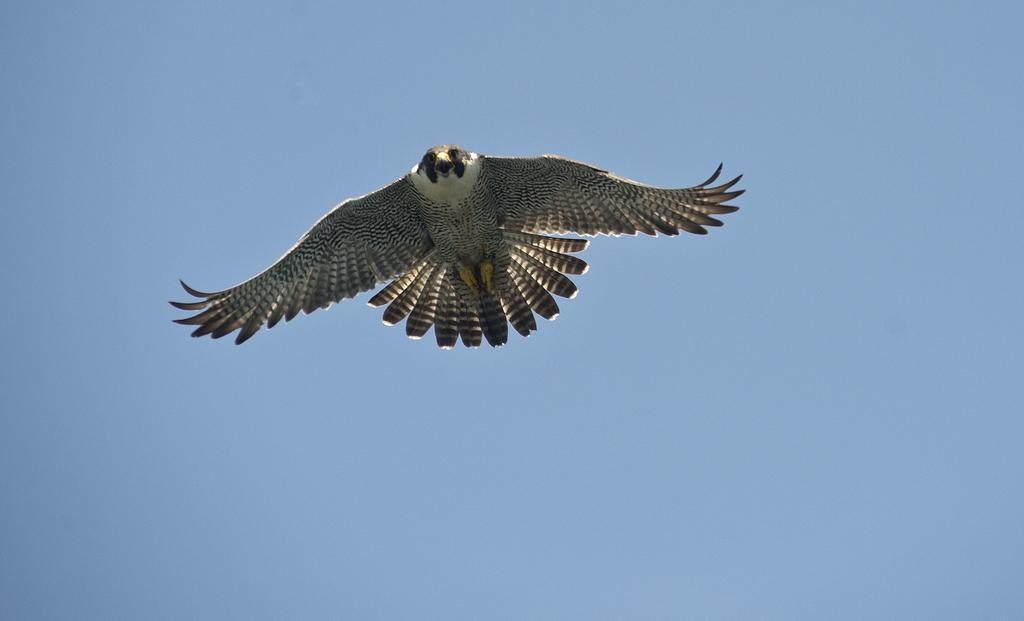What is the main subject of the image? The main subject of the image is a bird flying. Where is the bird located in the image? The bird is in the air in the image. What can be seen in the background of the image? The sky is visible in the image. What color is the sky in the image? The sky is blue in the image. What type of trade is happening in the image? There is no trade happening in the image; it features a bird flying in the blue sky. 